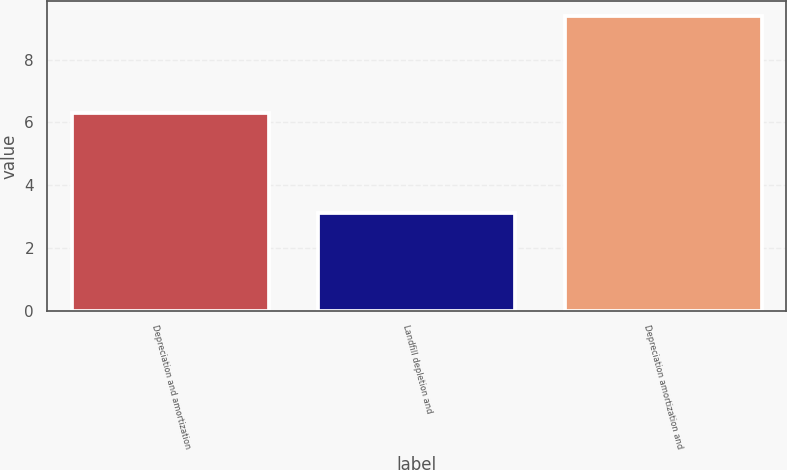Convert chart. <chart><loc_0><loc_0><loc_500><loc_500><bar_chart><fcel>Depreciation and amortization<fcel>Landfill depletion and<fcel>Depreciation amortization and<nl><fcel>6.3<fcel>3.1<fcel>9.4<nl></chart> 